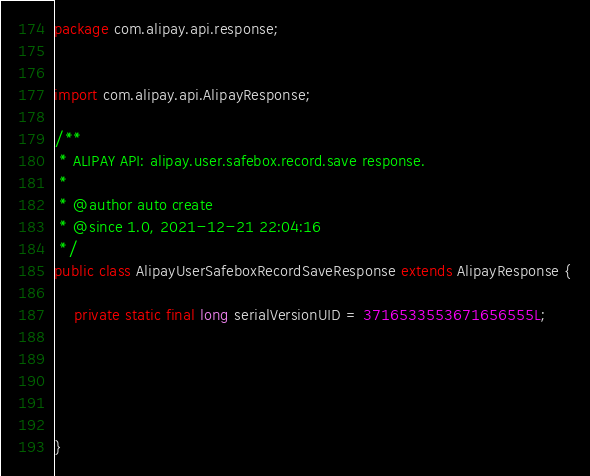<code> <loc_0><loc_0><loc_500><loc_500><_Java_>package com.alipay.api.response;


import com.alipay.api.AlipayResponse;

/**
 * ALIPAY API: alipay.user.safebox.record.save response.
 * 
 * @author auto create
 * @since 1.0, 2021-12-21 22:04:16
 */
public class AlipayUserSafeboxRecordSaveResponse extends AlipayResponse {

	private static final long serialVersionUID = 3716533553671656555L;

	

	

}
</code> 